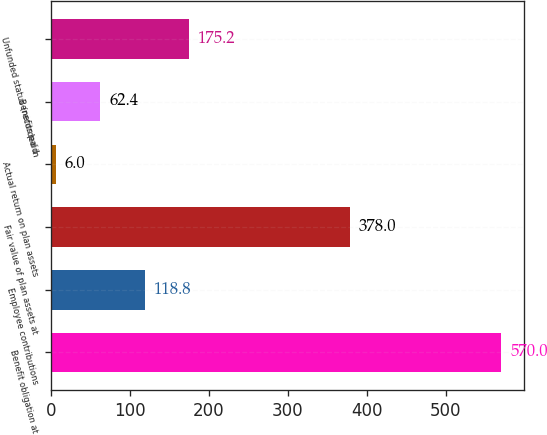<chart> <loc_0><loc_0><loc_500><loc_500><bar_chart><fcel>Benefit obligation at<fcel>Employee contributions<fcel>Fair value of plan assets at<fcel>Actual return on plan assets<fcel>Benefits paid<fcel>Unfunded status (recorded in<nl><fcel>570<fcel>118.8<fcel>378<fcel>6<fcel>62.4<fcel>175.2<nl></chart> 